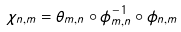<formula> <loc_0><loc_0><loc_500><loc_500>\chi _ { n , m } = \theta _ { m , n } \circ \phi _ { m , n } ^ { - 1 } \circ \phi _ { n , m }</formula> 